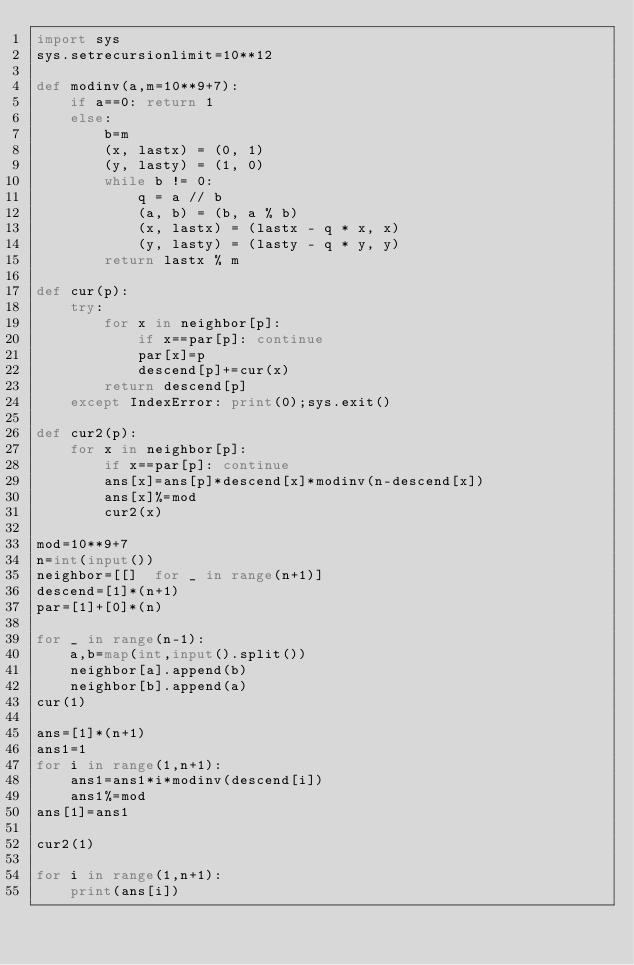Convert code to text. <code><loc_0><loc_0><loc_500><loc_500><_Python_>import sys
sys.setrecursionlimit=10**12

def modinv(a,m=10**9+7):
    if a==0: return 1
    else:
        b=m
        (x, lastx) = (0, 1)
        (y, lasty) = (1, 0)
        while b != 0:
            q = a // b
            (a, b) = (b, a % b)
            (x, lastx) = (lastx - q * x, x)
            (y, lasty) = (lasty - q * y, y)
        return lastx % m

def cur(p):
    try:
        for x in neighbor[p]:
            if x==par[p]: continue
            par[x]=p
            descend[p]+=cur(x)
        return descend[p]
    except IndexError: print(0);sys.exit()

def cur2(p):
    for x in neighbor[p]:
        if x==par[p]: continue
        ans[x]=ans[p]*descend[x]*modinv(n-descend[x])
        ans[x]%=mod
        cur2(x)

mod=10**9+7
n=int(input())
neighbor=[[]  for _ in range(n+1)]
descend=[1]*(n+1)
par=[1]+[0]*(n)

for _ in range(n-1):
    a,b=map(int,input().split())
    neighbor[a].append(b)
    neighbor[b].append(a)
cur(1)

ans=[1]*(n+1)
ans1=1
for i in range(1,n+1):
    ans1=ans1*i*modinv(descend[i])
    ans1%=mod
ans[1]=ans1

cur2(1)

for i in range(1,n+1):
    print(ans[i])
</code> 